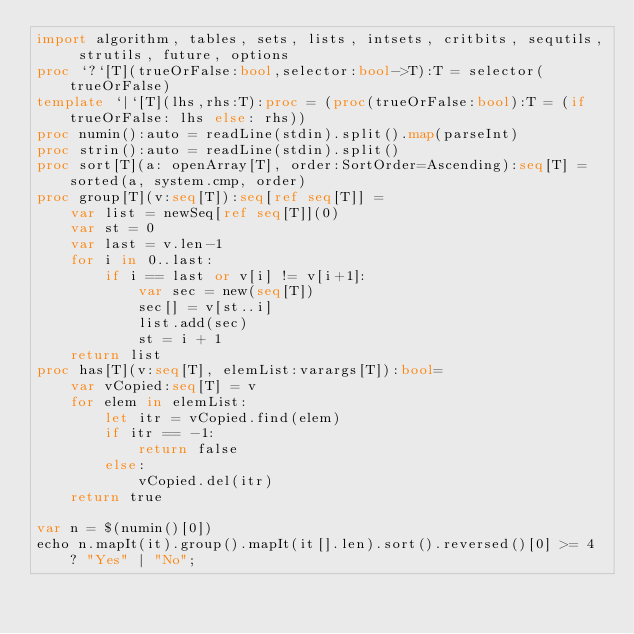<code> <loc_0><loc_0><loc_500><loc_500><_Nim_>import algorithm, tables, sets, lists, intsets, critbits, sequtils, strutils, future, options
proc `?`[T](trueOrFalse:bool,selector:bool->T):T = selector(trueOrFalse)
template `|`[T](lhs,rhs:T):proc = (proc(trueOrFalse:bool):T = (if trueOrFalse: lhs else: rhs))
proc numin():auto = readLine(stdin).split().map(parseInt)
proc strin():auto = readLine(stdin).split()
proc sort[T](a: openArray[T], order:SortOrder=Ascending):seq[T] = sorted(a, system.cmp, order)
proc group[T](v:seq[T]):seq[ref seq[T]] =
    var list = newSeq[ref seq[T]](0)
    var st = 0
    var last = v.len-1
    for i in 0..last:
        if i == last or v[i] != v[i+1]:
            var sec = new(seq[T])
            sec[] = v[st..i]
            list.add(sec)
            st = i + 1
    return list
proc has[T](v:seq[T], elemList:varargs[T]):bool=
    var vCopied:seq[T] = v
    for elem in elemList:
        let itr = vCopied.find(elem)
        if itr == -1:
            return false
        else:
            vCopied.del(itr)
    return true

var n = $(numin()[0])
echo n.mapIt(it).group().mapIt(it[].len).sort().reversed()[0] >= 4 ? "Yes" | "No";</code> 